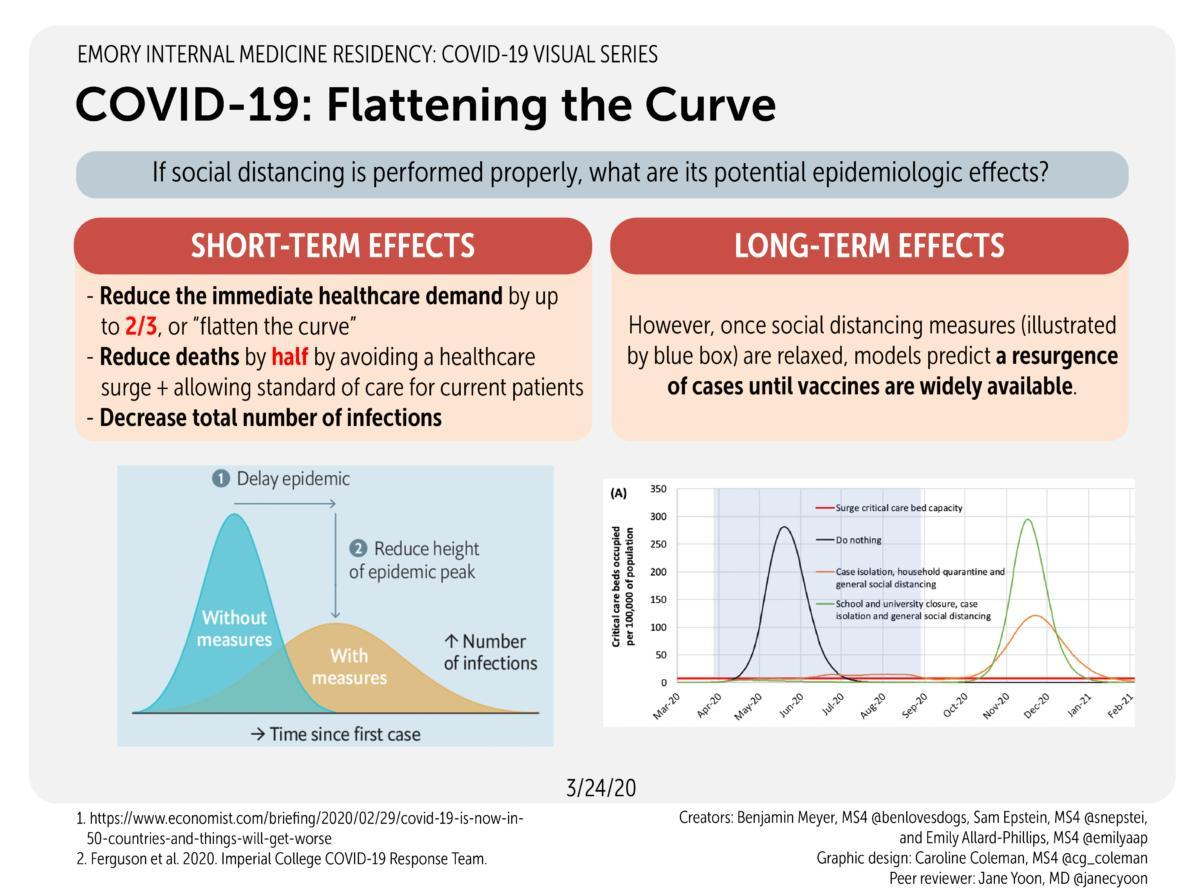If mandated restrictions are withdrawn, then which of the factor gets increase as given in the graph?
Answer the question with a short phrase. Number of infections Which curve has the second highest peak? Do nothing What is the social distancing approach to be followed to slow down the reporting of Covid cases? With measures What are the temporary results of introducing proper social distancing? Reduce the immediate healthcare demand, reduce deaths, Decrease total number of infections What is the color code given to the curve "with measures"- red, black, green, orange? orange How many points are listed under the heading Short-term effects? 3 What we can achieve by following proper social distancing among people as given in the graph? Delay epidemic, Reduce height of epidemic peak What is the color code given to the curve "without measures"- red, black, blue, white? blue 